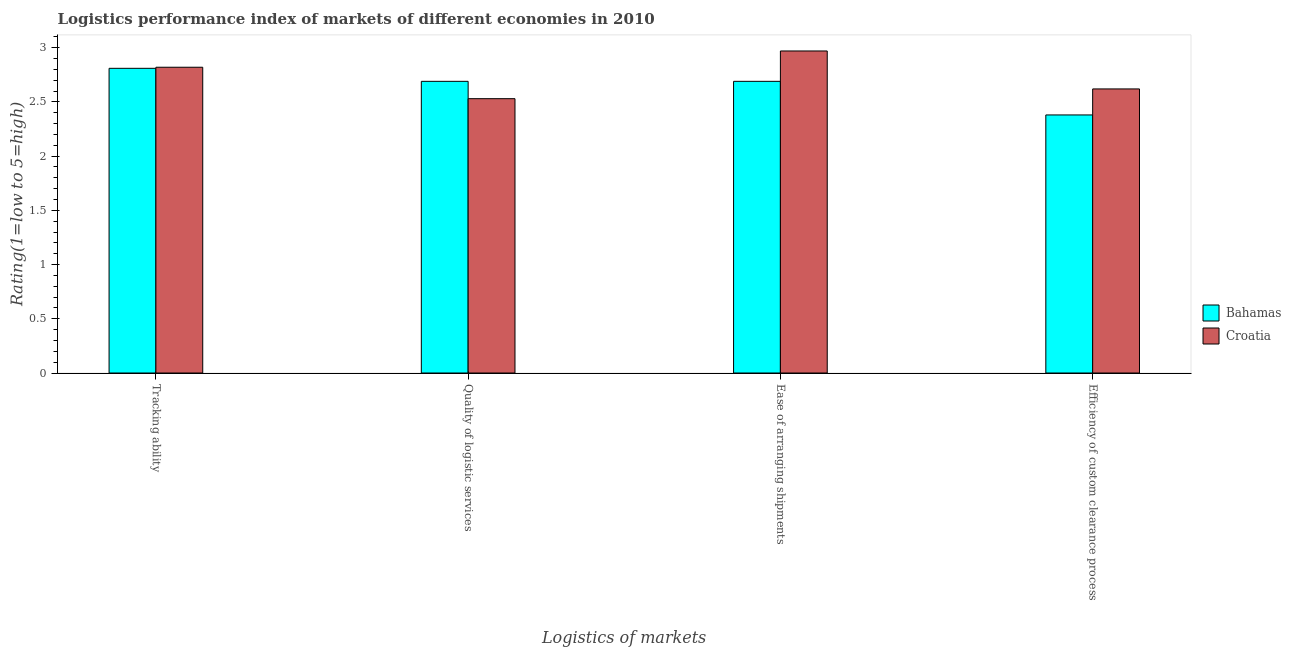How many different coloured bars are there?
Your answer should be very brief. 2. How many groups of bars are there?
Give a very brief answer. 4. Are the number of bars per tick equal to the number of legend labels?
Provide a succinct answer. Yes. How many bars are there on the 3rd tick from the left?
Offer a terse response. 2. What is the label of the 1st group of bars from the left?
Offer a very short reply. Tracking ability. What is the lpi rating of ease of arranging shipments in Bahamas?
Offer a very short reply. 2.69. Across all countries, what is the maximum lpi rating of tracking ability?
Offer a very short reply. 2.82. Across all countries, what is the minimum lpi rating of tracking ability?
Your response must be concise. 2.81. In which country was the lpi rating of tracking ability maximum?
Offer a terse response. Croatia. In which country was the lpi rating of efficiency of custom clearance process minimum?
Your answer should be compact. Bahamas. What is the total lpi rating of quality of logistic services in the graph?
Provide a short and direct response. 5.22. What is the difference between the lpi rating of quality of logistic services in Croatia and that in Bahamas?
Provide a succinct answer. -0.16. What is the difference between the lpi rating of tracking ability in Croatia and the lpi rating of efficiency of custom clearance process in Bahamas?
Keep it short and to the point. 0.44. What is the average lpi rating of ease of arranging shipments per country?
Your answer should be compact. 2.83. What is the difference between the lpi rating of quality of logistic services and lpi rating of tracking ability in Bahamas?
Offer a very short reply. -0.12. In how many countries, is the lpi rating of tracking ability greater than 0.6 ?
Provide a short and direct response. 2. What is the ratio of the lpi rating of tracking ability in Bahamas to that in Croatia?
Keep it short and to the point. 1. Is the difference between the lpi rating of efficiency of custom clearance process in Croatia and Bahamas greater than the difference between the lpi rating of ease of arranging shipments in Croatia and Bahamas?
Keep it short and to the point. No. What is the difference between the highest and the second highest lpi rating of efficiency of custom clearance process?
Your answer should be compact. 0.24. What is the difference between the highest and the lowest lpi rating of ease of arranging shipments?
Offer a very short reply. 0.28. What does the 1st bar from the left in Ease of arranging shipments represents?
Offer a terse response. Bahamas. What does the 1st bar from the right in Quality of logistic services represents?
Give a very brief answer. Croatia. Are all the bars in the graph horizontal?
Keep it short and to the point. No. What is the difference between two consecutive major ticks on the Y-axis?
Your answer should be very brief. 0.5. Are the values on the major ticks of Y-axis written in scientific E-notation?
Provide a succinct answer. No. What is the title of the graph?
Ensure brevity in your answer.  Logistics performance index of markets of different economies in 2010. What is the label or title of the X-axis?
Ensure brevity in your answer.  Logistics of markets. What is the label or title of the Y-axis?
Offer a very short reply. Rating(1=low to 5=high). What is the Rating(1=low to 5=high) in Bahamas in Tracking ability?
Ensure brevity in your answer.  2.81. What is the Rating(1=low to 5=high) in Croatia in Tracking ability?
Offer a terse response. 2.82. What is the Rating(1=low to 5=high) in Bahamas in Quality of logistic services?
Provide a succinct answer. 2.69. What is the Rating(1=low to 5=high) of Croatia in Quality of logistic services?
Ensure brevity in your answer.  2.53. What is the Rating(1=low to 5=high) of Bahamas in Ease of arranging shipments?
Provide a succinct answer. 2.69. What is the Rating(1=low to 5=high) in Croatia in Ease of arranging shipments?
Make the answer very short. 2.97. What is the Rating(1=low to 5=high) in Bahamas in Efficiency of custom clearance process?
Provide a short and direct response. 2.38. What is the Rating(1=low to 5=high) in Croatia in Efficiency of custom clearance process?
Keep it short and to the point. 2.62. Across all Logistics of markets, what is the maximum Rating(1=low to 5=high) of Bahamas?
Your answer should be very brief. 2.81. Across all Logistics of markets, what is the maximum Rating(1=low to 5=high) of Croatia?
Your answer should be compact. 2.97. Across all Logistics of markets, what is the minimum Rating(1=low to 5=high) of Bahamas?
Offer a terse response. 2.38. Across all Logistics of markets, what is the minimum Rating(1=low to 5=high) of Croatia?
Your answer should be very brief. 2.53. What is the total Rating(1=low to 5=high) in Bahamas in the graph?
Provide a short and direct response. 10.57. What is the total Rating(1=low to 5=high) of Croatia in the graph?
Your answer should be compact. 10.94. What is the difference between the Rating(1=low to 5=high) of Bahamas in Tracking ability and that in Quality of logistic services?
Ensure brevity in your answer.  0.12. What is the difference between the Rating(1=low to 5=high) in Croatia in Tracking ability and that in Quality of logistic services?
Your answer should be very brief. 0.29. What is the difference between the Rating(1=low to 5=high) in Bahamas in Tracking ability and that in Ease of arranging shipments?
Give a very brief answer. 0.12. What is the difference between the Rating(1=low to 5=high) in Croatia in Tracking ability and that in Ease of arranging shipments?
Offer a terse response. -0.15. What is the difference between the Rating(1=low to 5=high) in Bahamas in Tracking ability and that in Efficiency of custom clearance process?
Make the answer very short. 0.43. What is the difference between the Rating(1=low to 5=high) in Croatia in Tracking ability and that in Efficiency of custom clearance process?
Ensure brevity in your answer.  0.2. What is the difference between the Rating(1=low to 5=high) in Bahamas in Quality of logistic services and that in Ease of arranging shipments?
Your answer should be very brief. 0. What is the difference between the Rating(1=low to 5=high) of Croatia in Quality of logistic services and that in Ease of arranging shipments?
Provide a short and direct response. -0.44. What is the difference between the Rating(1=low to 5=high) in Bahamas in Quality of logistic services and that in Efficiency of custom clearance process?
Offer a terse response. 0.31. What is the difference between the Rating(1=low to 5=high) in Croatia in Quality of logistic services and that in Efficiency of custom clearance process?
Make the answer very short. -0.09. What is the difference between the Rating(1=low to 5=high) of Bahamas in Ease of arranging shipments and that in Efficiency of custom clearance process?
Give a very brief answer. 0.31. What is the difference between the Rating(1=low to 5=high) of Bahamas in Tracking ability and the Rating(1=low to 5=high) of Croatia in Quality of logistic services?
Your answer should be very brief. 0.28. What is the difference between the Rating(1=low to 5=high) of Bahamas in Tracking ability and the Rating(1=low to 5=high) of Croatia in Ease of arranging shipments?
Your response must be concise. -0.16. What is the difference between the Rating(1=low to 5=high) in Bahamas in Tracking ability and the Rating(1=low to 5=high) in Croatia in Efficiency of custom clearance process?
Offer a very short reply. 0.19. What is the difference between the Rating(1=low to 5=high) of Bahamas in Quality of logistic services and the Rating(1=low to 5=high) of Croatia in Ease of arranging shipments?
Your response must be concise. -0.28. What is the difference between the Rating(1=low to 5=high) in Bahamas in Quality of logistic services and the Rating(1=low to 5=high) in Croatia in Efficiency of custom clearance process?
Offer a terse response. 0.07. What is the difference between the Rating(1=low to 5=high) of Bahamas in Ease of arranging shipments and the Rating(1=low to 5=high) of Croatia in Efficiency of custom clearance process?
Ensure brevity in your answer.  0.07. What is the average Rating(1=low to 5=high) of Bahamas per Logistics of markets?
Your answer should be very brief. 2.64. What is the average Rating(1=low to 5=high) of Croatia per Logistics of markets?
Provide a succinct answer. 2.73. What is the difference between the Rating(1=low to 5=high) in Bahamas and Rating(1=low to 5=high) in Croatia in Tracking ability?
Provide a succinct answer. -0.01. What is the difference between the Rating(1=low to 5=high) of Bahamas and Rating(1=low to 5=high) of Croatia in Quality of logistic services?
Provide a succinct answer. 0.16. What is the difference between the Rating(1=low to 5=high) of Bahamas and Rating(1=low to 5=high) of Croatia in Ease of arranging shipments?
Offer a very short reply. -0.28. What is the difference between the Rating(1=low to 5=high) of Bahamas and Rating(1=low to 5=high) of Croatia in Efficiency of custom clearance process?
Give a very brief answer. -0.24. What is the ratio of the Rating(1=low to 5=high) of Bahamas in Tracking ability to that in Quality of logistic services?
Offer a terse response. 1.04. What is the ratio of the Rating(1=low to 5=high) in Croatia in Tracking ability to that in Quality of logistic services?
Your answer should be very brief. 1.11. What is the ratio of the Rating(1=low to 5=high) of Bahamas in Tracking ability to that in Ease of arranging shipments?
Your response must be concise. 1.04. What is the ratio of the Rating(1=low to 5=high) of Croatia in Tracking ability to that in Ease of arranging shipments?
Keep it short and to the point. 0.95. What is the ratio of the Rating(1=low to 5=high) of Bahamas in Tracking ability to that in Efficiency of custom clearance process?
Keep it short and to the point. 1.18. What is the ratio of the Rating(1=low to 5=high) in Croatia in Tracking ability to that in Efficiency of custom clearance process?
Provide a succinct answer. 1.08. What is the ratio of the Rating(1=low to 5=high) of Croatia in Quality of logistic services to that in Ease of arranging shipments?
Your answer should be very brief. 0.85. What is the ratio of the Rating(1=low to 5=high) in Bahamas in Quality of logistic services to that in Efficiency of custom clearance process?
Keep it short and to the point. 1.13. What is the ratio of the Rating(1=low to 5=high) in Croatia in Quality of logistic services to that in Efficiency of custom clearance process?
Offer a terse response. 0.97. What is the ratio of the Rating(1=low to 5=high) of Bahamas in Ease of arranging shipments to that in Efficiency of custom clearance process?
Provide a succinct answer. 1.13. What is the ratio of the Rating(1=low to 5=high) in Croatia in Ease of arranging shipments to that in Efficiency of custom clearance process?
Your answer should be compact. 1.13. What is the difference between the highest and the second highest Rating(1=low to 5=high) in Bahamas?
Provide a short and direct response. 0.12. What is the difference between the highest and the lowest Rating(1=low to 5=high) of Bahamas?
Give a very brief answer. 0.43. What is the difference between the highest and the lowest Rating(1=low to 5=high) of Croatia?
Offer a very short reply. 0.44. 